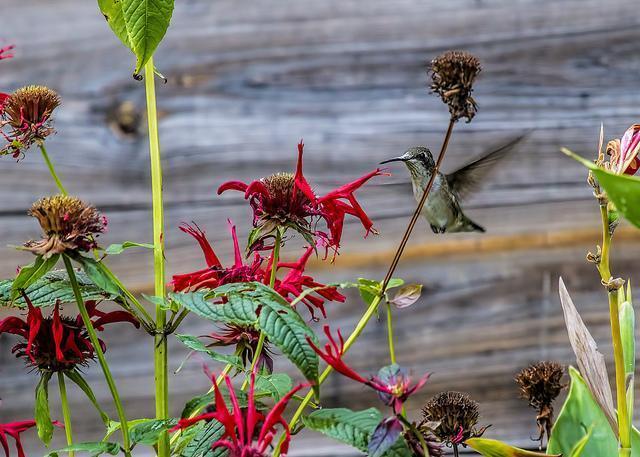How many birds are there?
Give a very brief answer. 1. How many people in this image are dragging a suitcase behind them?
Give a very brief answer. 0. 